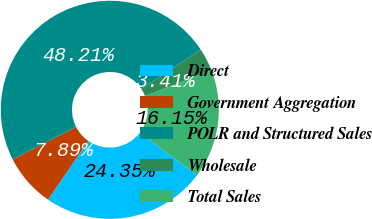Convert chart. <chart><loc_0><loc_0><loc_500><loc_500><pie_chart><fcel>Direct<fcel>Government Aggregation<fcel>POLR and Structured Sales<fcel>Wholesale<fcel>Total Sales<nl><fcel>24.35%<fcel>7.89%<fcel>48.21%<fcel>3.41%<fcel>16.15%<nl></chart> 